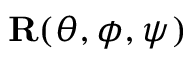Convert formula to latex. <formula><loc_0><loc_0><loc_500><loc_500>{ R } ( \theta , \phi , \psi )</formula> 